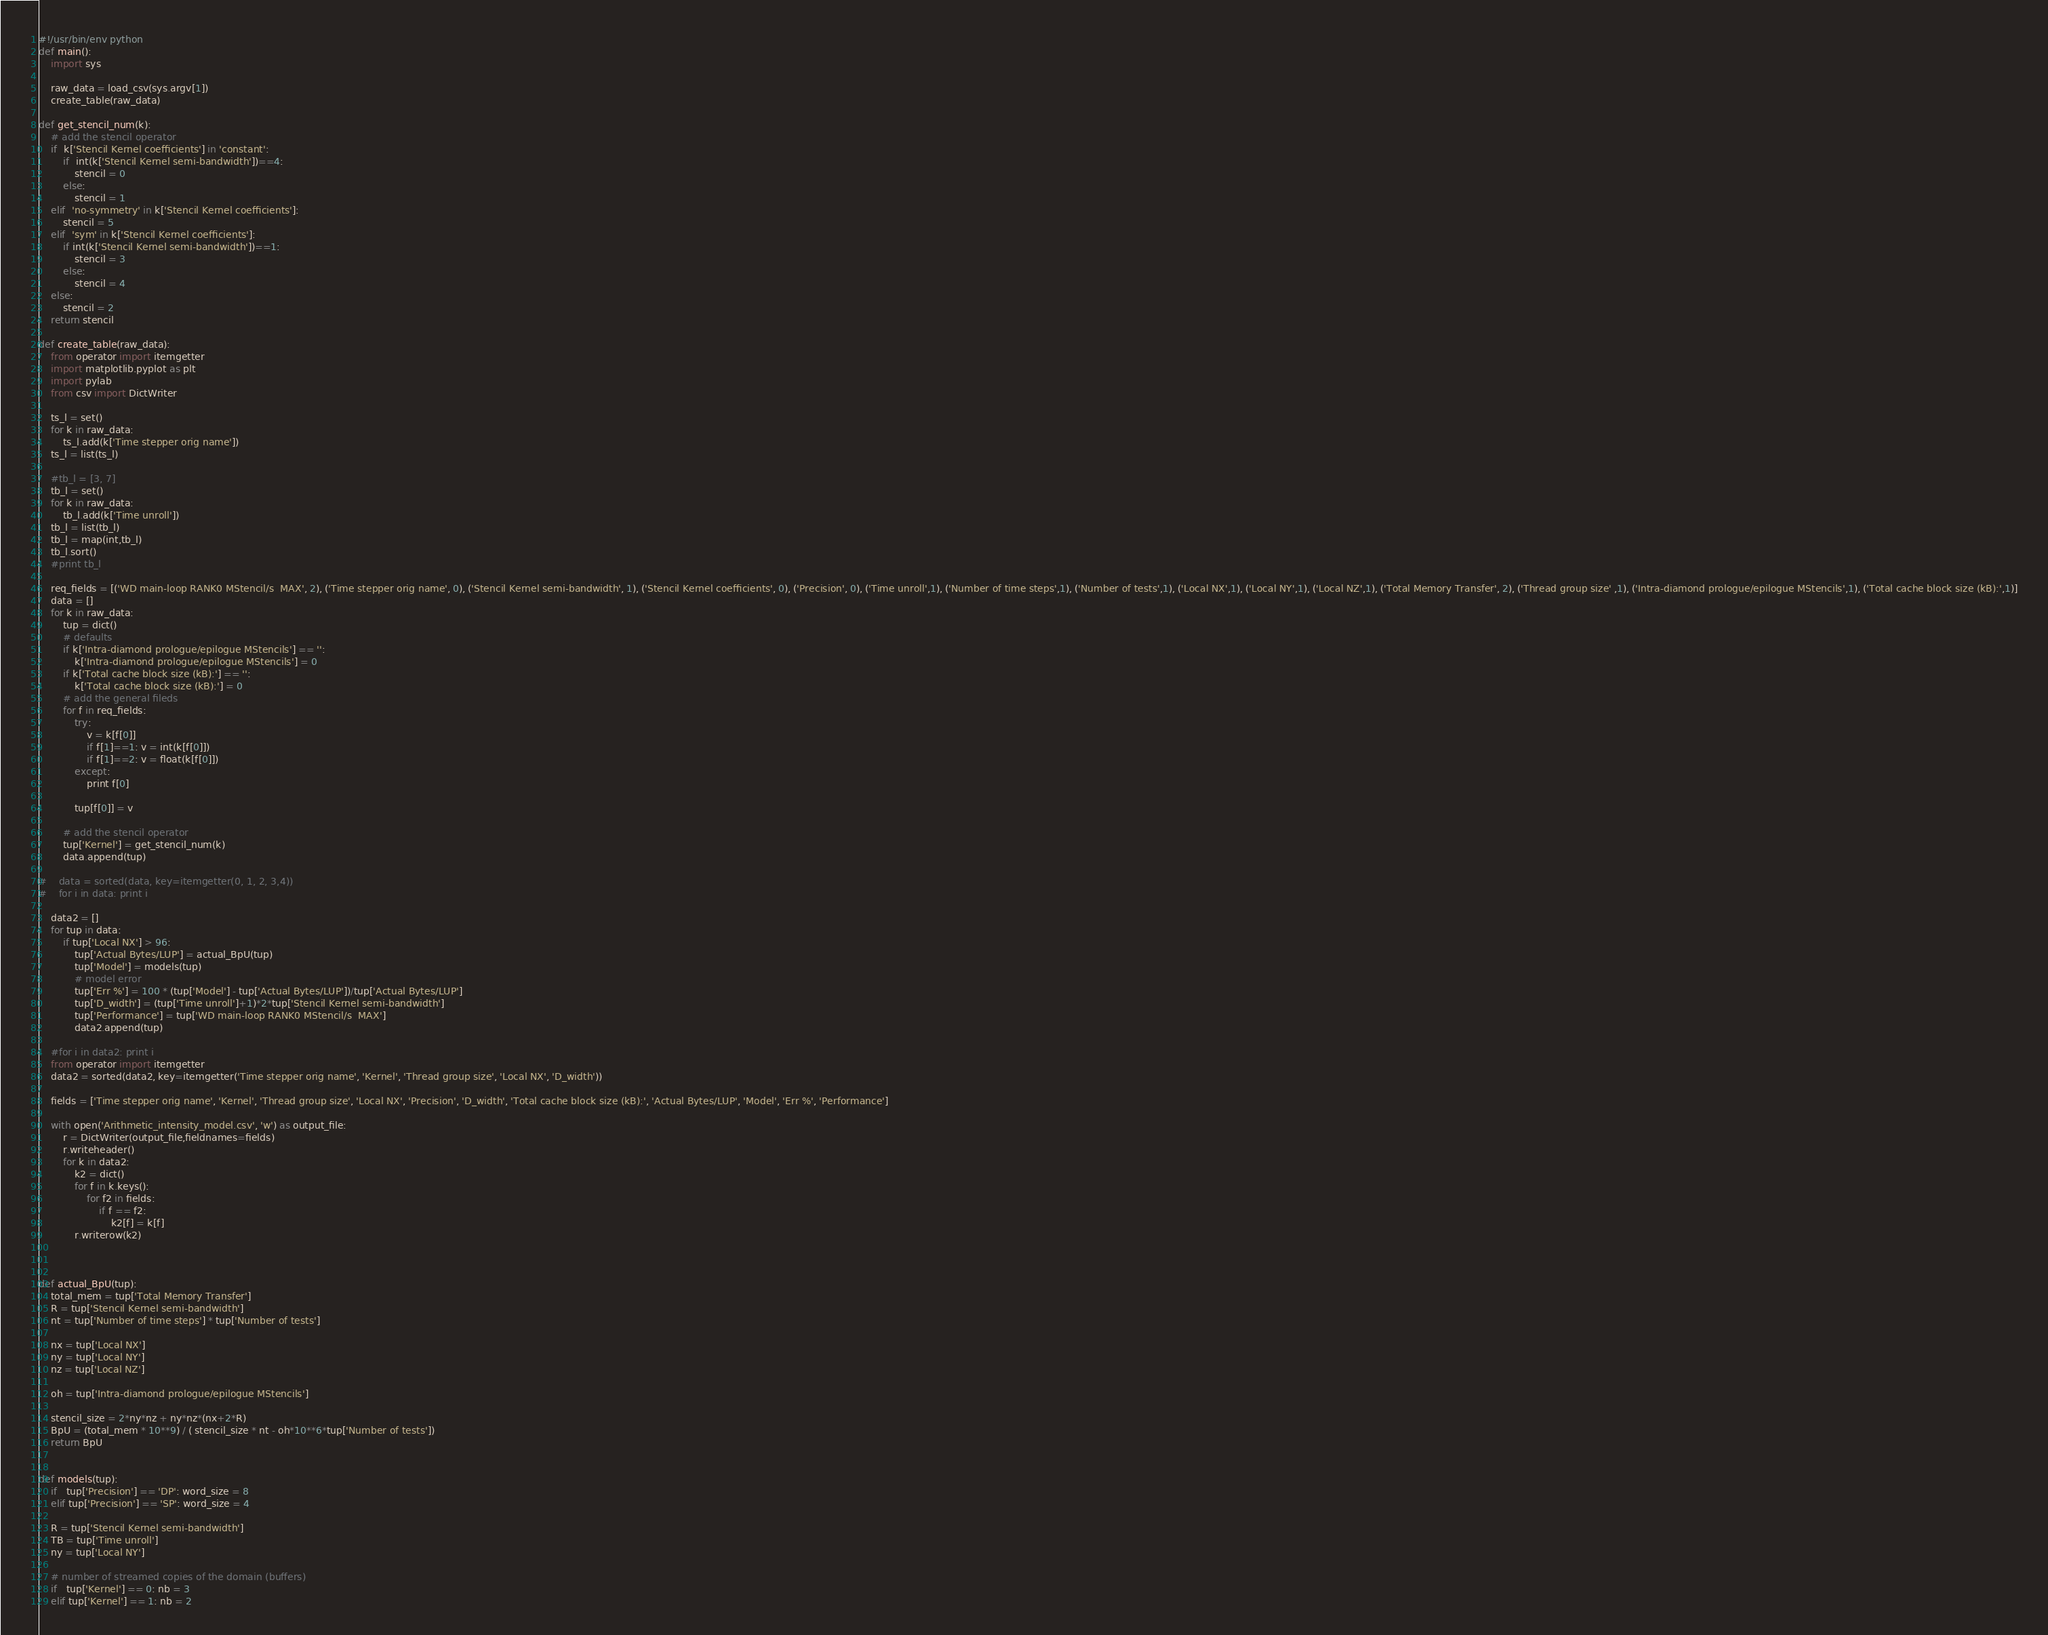Convert code to text. <code><loc_0><loc_0><loc_500><loc_500><_Python_>#!/usr/bin/env python
def main():
    import sys

    raw_data = load_csv(sys.argv[1])
    create_table(raw_data)

def get_stencil_num(k):
    # add the stencil operator
    if  k['Stencil Kernel coefficients'] in 'constant':
        if  int(k['Stencil Kernel semi-bandwidth'])==4:
            stencil = 0
        else:
            stencil = 1
    elif  'no-symmetry' in k['Stencil Kernel coefficients']:
        stencil = 5
    elif  'sym' in k['Stencil Kernel coefficients']:
        if int(k['Stencil Kernel semi-bandwidth'])==1:
            stencil = 3
        else:
            stencil = 4
    else:
        stencil = 2
    return stencil

def create_table(raw_data):
    from operator import itemgetter
    import matplotlib.pyplot as plt
    import pylab
    from csv import DictWriter

    ts_l = set()
    for k in raw_data:
        ts_l.add(k['Time stepper orig name'])
    ts_l = list(ts_l)

    #tb_l = [3, 7]
    tb_l = set()
    for k in raw_data:
        tb_l.add(k['Time unroll'])
    tb_l = list(tb_l)
    tb_l = map(int,tb_l)
    tb_l.sort()
    #print tb_l

    req_fields = [('WD main-loop RANK0 MStencil/s  MAX', 2), ('Time stepper orig name', 0), ('Stencil Kernel semi-bandwidth', 1), ('Stencil Kernel coefficients', 0), ('Precision', 0), ('Time unroll',1), ('Number of time steps',1), ('Number of tests',1), ('Local NX',1), ('Local NY',1), ('Local NZ',1), ('Total Memory Transfer', 2), ('Thread group size' ,1), ('Intra-diamond prologue/epilogue MStencils',1), ('Total cache block size (kB):',1)]
    data = []
    for k in raw_data:
        tup = dict()
        # defaults
        if k['Intra-diamond prologue/epilogue MStencils'] == '':
            k['Intra-diamond prologue/epilogue MStencils'] = 0
        if k['Total cache block size (kB):'] == '':
            k['Total cache block size (kB):'] = 0
        # add the general fileds
        for f in req_fields:
            try:
                v = k[f[0]]
                if f[1]==1: v = int(k[f[0]]) 
                if f[1]==2: v = float(k[f[0]]) 
            except:
                print f[0]
                    
            tup[f[0]] = v

        # add the stencil operator
        tup['Kernel'] = get_stencil_num(k)
        data.append(tup)

#    data = sorted(data, key=itemgetter(0, 1, 2, 3,4))
#    for i in data: print i

    data2 = []
    for tup in data:
        if tup['Local NX'] > 96:
            tup['Actual Bytes/LUP'] = actual_BpU(tup)
            tup['Model'] = models(tup)
            # model error
            tup['Err %'] = 100 * (tup['Model'] - tup['Actual Bytes/LUP'])/tup['Actual Bytes/LUP']
            tup['D_width'] = (tup['Time unroll']+1)*2*tup['Stencil Kernel semi-bandwidth']
            tup['Performance'] = tup['WD main-loop RANK0 MStencil/s  MAX']
            data2.append(tup)

    #for i in data2: print i
    from operator import itemgetter
    data2 = sorted(data2, key=itemgetter('Time stepper orig name', 'Kernel', 'Thread group size', 'Local NX', 'D_width'))

    fields = ['Time stepper orig name', 'Kernel', 'Thread group size', 'Local NX', 'Precision', 'D_width', 'Total cache block size (kB):', 'Actual Bytes/LUP', 'Model', 'Err %', 'Performance']

    with open('Arithmetic_intensity_model.csv', 'w') as output_file:
        r = DictWriter(output_file,fieldnames=fields)
        r.writeheader()
        for k in data2:
            k2 = dict()
            for f in k.keys():
                for f2 in fields:
                    if f == f2:
                        k2[f] = k[f]
            r.writerow(k2)

   

def actual_BpU(tup):
    total_mem = tup['Total Memory Transfer']
    R = tup['Stencil Kernel semi-bandwidth']
    nt = tup['Number of time steps'] * tup['Number of tests']

    nx = tup['Local NX']
    ny = tup['Local NY']
    nz = tup['Local NZ']

    oh = tup['Intra-diamond prologue/epilogue MStencils']

    stencil_size = 2*ny*nz + ny*nz*(nx+2*R) 
    BpU = (total_mem * 10**9) / ( stencil_size * nt - oh*10**6*tup['Number of tests'])
    return BpU


def models(tup):
    if   tup['Precision'] == 'DP': word_size = 8
    elif tup['Precision'] == 'SP': word_size = 4

    R = tup['Stencil Kernel semi-bandwidth']
    TB = tup['Time unroll']
    ny = tup['Local NY']

    # number of streamed copies of the domain (buffers)
    if   tup['Kernel'] == 0: nb = 3
    elif tup['Kernel'] == 1: nb = 2</code> 